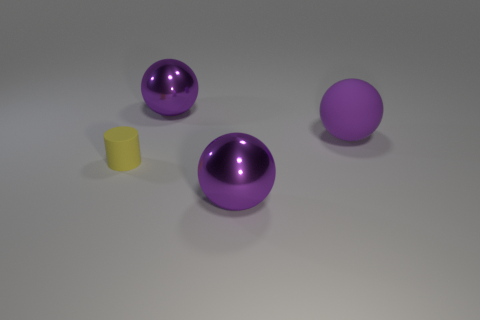How many purple spheres must be subtracted to get 1 purple spheres? 2 Subtract all purple cylinders. Subtract all red blocks. How many cylinders are left? 1 Add 3 matte things. How many objects exist? 7 Subtract all spheres. How many objects are left? 1 Add 3 large purple metallic spheres. How many large purple metallic spheres are left? 5 Add 3 small blue shiny things. How many small blue shiny things exist? 3 Subtract 0 gray blocks. How many objects are left? 4 Subtract all purple rubber spheres. Subtract all tiny yellow matte cylinders. How many objects are left? 2 